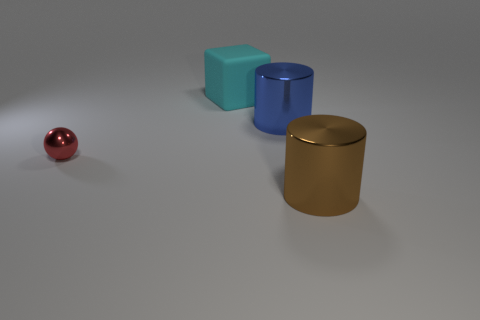How many things are things on the left side of the big cyan thing or shiny things that are on the left side of the large cyan object?
Keep it short and to the point. 1. What is the shape of the big brown shiny object?
Give a very brief answer. Cylinder. What number of green cylinders have the same material as the big brown cylinder?
Your answer should be very brief. 0. The block has what color?
Offer a very short reply. Cyan. There is another cylinder that is the same size as the blue shiny cylinder; what is its color?
Ensure brevity in your answer.  Brown. There is a large matte object that is to the left of the brown metallic thing; is it the same shape as the large metallic thing behind the big brown shiny cylinder?
Give a very brief answer. No. How many other things are the same size as the red ball?
Your response must be concise. 0. Is the number of objects that are behind the matte block less than the number of objects to the left of the blue cylinder?
Give a very brief answer. Yes. There is a object that is on the right side of the cyan block and in front of the large blue metallic cylinder; what is its color?
Give a very brief answer. Brown. Do the brown cylinder and the blue cylinder that is right of the ball have the same size?
Offer a terse response. Yes. 